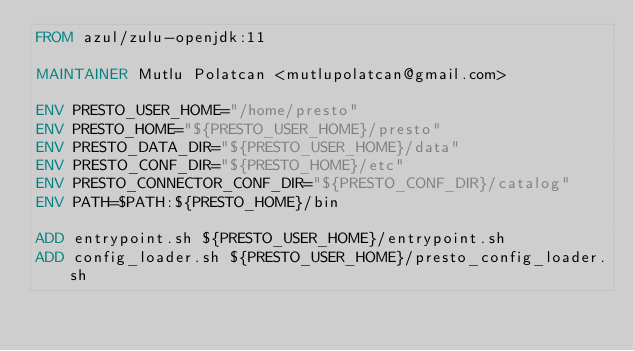<code> <loc_0><loc_0><loc_500><loc_500><_Dockerfile_>FROM azul/zulu-openjdk:11

MAINTAINER Mutlu Polatcan <mutlupolatcan@gmail.com>

ENV PRESTO_USER_HOME="/home/presto"
ENV PRESTO_HOME="${PRESTO_USER_HOME}/presto"
ENV PRESTO_DATA_DIR="${PRESTO_USER_HOME}/data"
ENV PRESTO_CONF_DIR="${PRESTO_HOME}/etc"
ENV PRESTO_CONNECTOR_CONF_DIR="${PRESTO_CONF_DIR}/catalog"
ENV PATH=$PATH:${PRESTO_HOME}/bin

ADD entrypoint.sh ${PRESTO_USER_HOME}/entrypoint.sh
ADD config_loader.sh ${PRESTO_USER_HOME}/presto_config_loader.sh</code> 